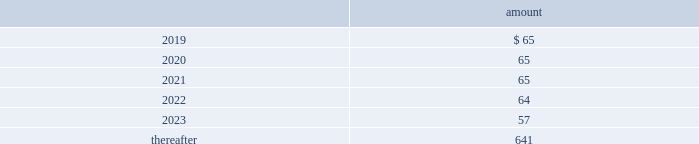Totaled $ 12 million , $ 13 million and $ 9 million for 2018 , 2017 and 2016 , respectively .
All of the company 2019s contributions are invested in one or more funds at the direction of the employees .
Note 16 : commitments and contingencies commitments have been made in connection with certain construction programs .
The estimated capital expenditures required under legal and binding contractual obligations amounted to $ 419 million as of december 31 , 2018 .
The company 2019s regulated subsidiaries maintain agreements with other water purveyors for the purchase of water to supplement their water supply .
The table provides the future annual commitments related to minimum quantities of purchased water having non-cancelable: .
The company enters into agreements for the provision of services to water and wastewater facilities for the united states military , municipalities and other customers .
See note 3 2014revenue recognition for additional information regarding the company 2019s performance obligations .
Contingencies the company is routinely involved in legal actions incident to the normal conduct of its business .
As of december 31 , 2018 , the company has accrued approximately $ 54 million of probable loss contingencies and has estimated that the maximum amount of losses associated with reasonably possible loss contingencies that can be reasonably estimated is $ 26 million .
For certain matters , claims and actions , the company is unable to estimate possible losses .
The company believes that damages or settlements , if any , recovered by plaintiffs in such matters , claims or actions , other than as described in this note 16 2014commitments and contingencies , will not have a material adverse effect on the company .
West virginia elk river freedom industries chemical spill on june 8 , 2018 , the u.s .
District court for the southern district of west virginia granted final approval of a settlement class and global class action settlement ( the 201csettlement 201d ) for all claims and potential claims by all putative class members ( collectively , the 201cplaintiffs 201d ) arising out of the january 2014 freedom industries , inc .
Chemical spill in west virginia .
The effective date of the settlement is july 16 , 2018 .
Under the terms and conditions of the settlement , west virginia-american water company ( 201cwvawc 201d ) and certain other company affiliated entities ( collectively , the 201camerican water defendants 201d ) did not admit , and will not admit , any fault or liability for any of the allegations made by the plaintiffs in any of the actions that were resolved .
Under federal class action rules , claimants had the right , until december 8 , 2017 , to elect to opt out of the final settlement .
Less than 100 of the 225000 estimated putative class members elected to opt out from the settlement , and these claimants will not receive any benefit from or be bound by the terms of the settlement .
In june 2018 , the company and its remaining non-participating general liability insurance carrier settled for a payment to the company of $ 20 million , out of a maximum of $ 25 million in potential coverage under the terms of the relevant policy , in exchange for a full release by the american water defendants of all claims against the insurance carrier related to the freedom industries chemical spill. .
As of december 31 , 2018 , what was the total accrued for probable loss contingencies and reasonably possible loss contingencies in $ million? 
Computations: (54 + 26)
Answer: 80.0. Totaled $ 12 million , $ 13 million and $ 9 million for 2018 , 2017 and 2016 , respectively .
All of the company 2019s contributions are invested in one or more funds at the direction of the employees .
Note 16 : commitments and contingencies commitments have been made in connection with certain construction programs .
The estimated capital expenditures required under legal and binding contractual obligations amounted to $ 419 million as of december 31 , 2018 .
The company 2019s regulated subsidiaries maintain agreements with other water purveyors for the purchase of water to supplement their water supply .
The table provides the future annual commitments related to minimum quantities of purchased water having non-cancelable: .
The company enters into agreements for the provision of services to water and wastewater facilities for the united states military , municipalities and other customers .
See note 3 2014revenue recognition for additional information regarding the company 2019s performance obligations .
Contingencies the company is routinely involved in legal actions incident to the normal conduct of its business .
As of december 31 , 2018 , the company has accrued approximately $ 54 million of probable loss contingencies and has estimated that the maximum amount of losses associated with reasonably possible loss contingencies that can be reasonably estimated is $ 26 million .
For certain matters , claims and actions , the company is unable to estimate possible losses .
The company believes that damages or settlements , if any , recovered by plaintiffs in such matters , claims or actions , other than as described in this note 16 2014commitments and contingencies , will not have a material adverse effect on the company .
West virginia elk river freedom industries chemical spill on june 8 , 2018 , the u.s .
District court for the southern district of west virginia granted final approval of a settlement class and global class action settlement ( the 201csettlement 201d ) for all claims and potential claims by all putative class members ( collectively , the 201cplaintiffs 201d ) arising out of the january 2014 freedom industries , inc .
Chemical spill in west virginia .
The effective date of the settlement is july 16 , 2018 .
Under the terms and conditions of the settlement , west virginia-american water company ( 201cwvawc 201d ) and certain other company affiliated entities ( collectively , the 201camerican water defendants 201d ) did not admit , and will not admit , any fault or liability for any of the allegations made by the plaintiffs in any of the actions that were resolved .
Under federal class action rules , claimants had the right , until december 8 , 2017 , to elect to opt out of the final settlement .
Less than 100 of the 225000 estimated putative class members elected to opt out from the settlement , and these claimants will not receive any benefit from or be bound by the terms of the settlement .
In june 2018 , the company and its remaining non-participating general liability insurance carrier settled for a payment to the company of $ 20 million , out of a maximum of $ 25 million in potential coverage under the terms of the relevant policy , in exchange for a full release by the american water defendants of all claims against the insurance carrier related to the freedom industries chemical spill. .
What percentage of future annual commitments related to minimum quantities of purchased water having non-cancelable are due after 2023? 
Rationale: the $ 957 above is the total amount . from here you need to take the total amount due "thereafter" or 641 and divide it by $ 957 to get 67% ( 641/957 = 67% )
Computations: (((65 + 65) + (65 + 64)) + (57 + 641))
Answer: 957.0. 